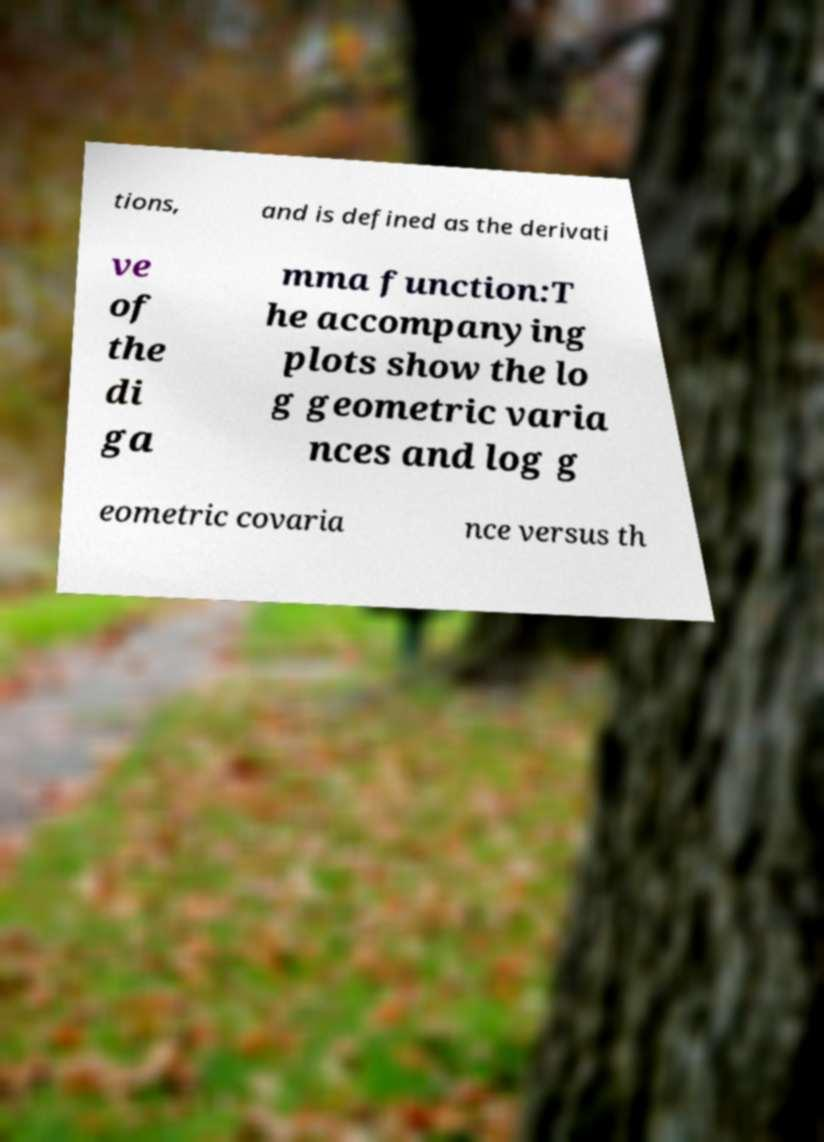Can you accurately transcribe the text from the provided image for me? tions, and is defined as the derivati ve of the di ga mma function:T he accompanying plots show the lo g geometric varia nces and log g eometric covaria nce versus th 